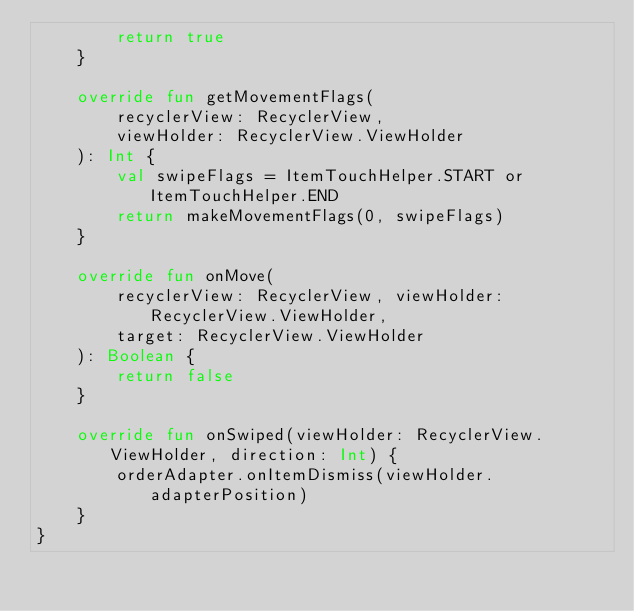Convert code to text. <code><loc_0><loc_0><loc_500><loc_500><_Kotlin_>        return true
    }

    override fun getMovementFlags(
        recyclerView: RecyclerView,
        viewHolder: RecyclerView.ViewHolder
    ): Int {
        val swipeFlags = ItemTouchHelper.START or ItemTouchHelper.END
        return makeMovementFlags(0, swipeFlags)
    }

    override fun onMove(
        recyclerView: RecyclerView, viewHolder: RecyclerView.ViewHolder,
        target: RecyclerView.ViewHolder
    ): Boolean {
        return false
    }

    override fun onSwiped(viewHolder: RecyclerView.ViewHolder, direction: Int) {
        orderAdapter.onItemDismiss(viewHolder.adapterPosition)
    }
}</code> 